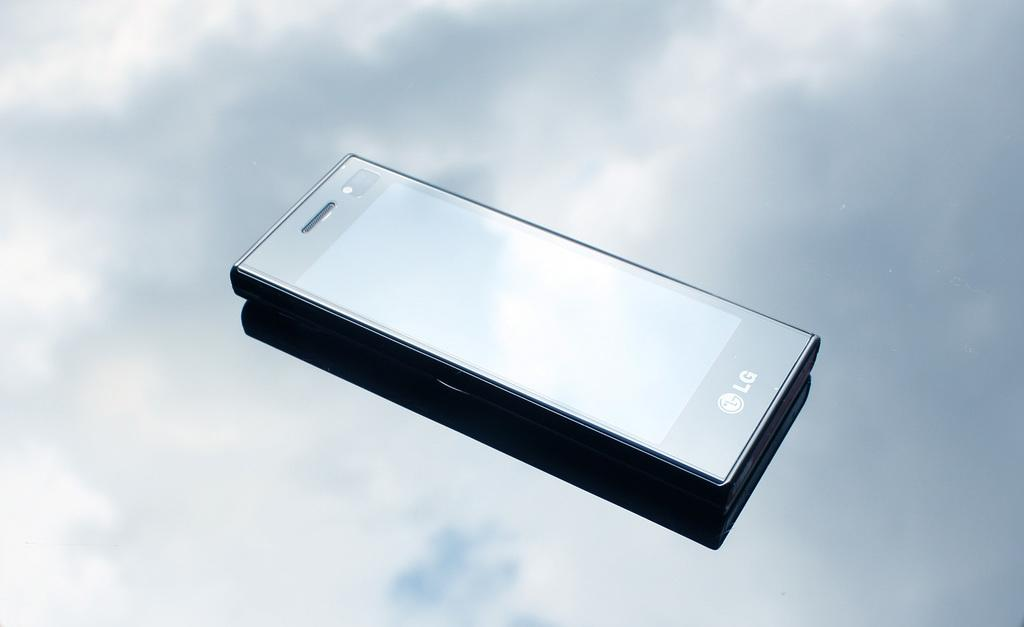<image>
Share a concise interpretation of the image provided. An LG phone is shown at an angle with clouds in the background. 